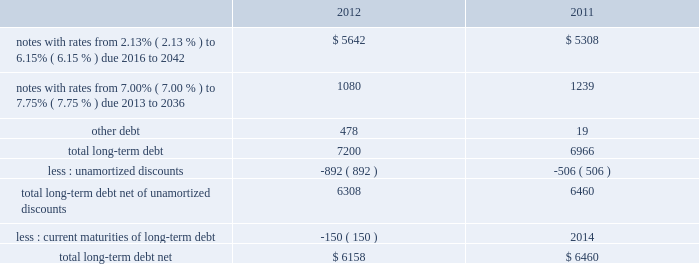Note 8 2013 debt our long-term debt consisted of the following ( in millions ) : .
In december 2012 , we issued notes totaling $ 1.3 billion with a fixed interest rate of 4.07% ( 4.07 % ) maturing in december 2042 ( the new notes ) in exchange for outstanding notes totaling $ 1.2 billion with interest rates ranging from 5.50% ( 5.50 % ) to 8.50% ( 8.50 % ) maturing in 2023 to 2040 ( the old notes ) .
In connection with the exchange , we paid a premium of $ 393 million , of which $ 225 million was paid in cash and $ 168 million was in the form of new notes .
This premium , in addition to $ 194 million in remaining unamortized discounts related to the old notes , will be amortized as additional interest expense over the term of the new notes using the effective interest method .
We may , at our option , redeem some or all of the new notes at any time by paying the principal amount of notes being redeemed plus a make-whole premium and accrued and unpaid interest .
Interest on the new notes is payable on june 15 and december 15 of each year , beginning on june 15 , 2013 .
The new notes are unsecured senior obligations and rank equally in right of payment with all of our existing and future unsecured and unsubordinated indebtedness .
On september 9 , 2011 , we issued $ 2.0 billion of long-term notes in a registered public offering consisting of $ 500 million maturing in 2016 with a fixed interest rate of 2.13% ( 2.13 % ) , $ 900 million maturing in 2021 with a fixed interest rate of 3.35% ( 3.35 % ) , and $ 600 million maturing in 2041 with a fixed interest rate of 4.85% ( 4.85 % ) .
We may , at our option , redeem some or all of the notes at any time by paying the principal amount of notes being redeemed plus a make-whole premium and accrued and unpaid interest .
Interest on the notes is payable on march 15 and september 15 of each year , beginning on march 15 , 2012 .
In october 2011 , we used a portion of the proceeds to redeem all of our $ 500 million long-term notes maturing in 2013 .
In 2011 , we repurchased $ 84 million of our long-term notes through open-market purchases .
We paid premiums of $ 48 million in connection with the early extinguishments of debt , which were recognized in other non-operating income ( expense ) , net .
In august 2011 , we entered into a $ 1.5 billion revolving credit facility with a group of banks and terminated our existing $ 1.5 billion revolving credit facility that was to expire in june 2012 .
The credit facility expires august 2016 , and we may request and the banks may grant , at their discretion , an increase to the credit facility by an additional amount up to $ 500 million .
There were no borrowings outstanding under either facility through december 31 , 2012 .
Borrowings under the credit facility would be unsecured and bear interest at rates based , at our option , on a eurodollar rate or a base rate , as defined in the credit facility .
Each bank 2019s obligation to make loans under the credit facility is subject to , among other things , our compliance with various representations , warranties and covenants , including covenants limiting our ability and certain of our subsidiaries 2019 ability to encumber assets and a covenant not to exceed a maximum leverage ratio , as defined in the credit facility .
The leverage ratio covenant excludes the adjustments recognized in stockholders 2019 equity related to postretirement benefit plans .
As of december 31 , 2012 , we were in compliance with all covenants contained in the credit facility , as well as in our debt agreements .
We have agreements in place with banking institutions to provide for the issuance of commercial paper .
There were no commercial paper borrowings outstanding during 2012 or 2011 .
If we were to issue commercial paper , the borrowings would be supported by the credit facility .
During the next five years , we have scheduled long-term debt maturities of $ 150 million due in 2013 and $ 952 million due in 2016 .
Interest payments were $ 378 million in 2012 , $ 326 million in 2011 , and $ 337 million in 2010. .
What was the percent change of the total long-term debt from 2011 to 2012? 
Computations: ((7200 - 6966) / 6966)
Answer: 0.03359. 